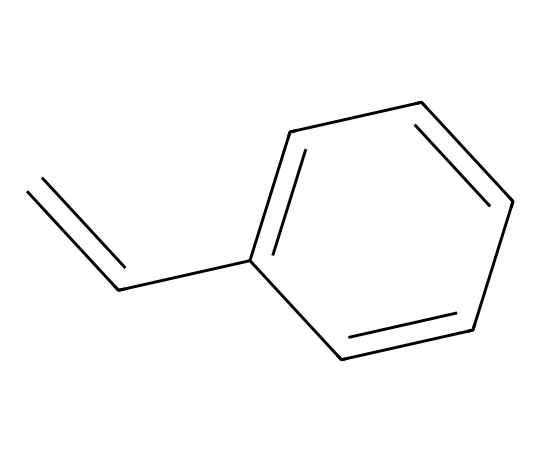What is the molecular formula of styrene? To determine the molecular formula, we first count the number of carbons (C) and hydrogens (H) in the structure. There are 8 carbon atoms and 8 hydrogen atoms. Thus, the molecular formula can be written as C8H8.
Answer: C8H8 How many double bonds are present in styrene? By examining the structure, we see one double bond between the first carbon (C) and the second carbon (C). Therefore, there is one double bond in the chemical structure.
Answer: 1 Which type of hybridization is present at the double bond of styrene? The carbon atoms involved in the double bond undergo sp2 hybridization due to one sigma bond and one pi bond formed. Thus, the hybridization at the double bond is sp2.
Answer: sp2 What type of polymer does styrene typically produce? Styrene is typically used to produce polystyrene, a well-known synthetic polymer used in various applications. Thus, the polymer produced from styrene is known as polystyrene.
Answer: polystyrene What property of styrene contributes to its use in copolymerization? The presence of the vinyl group (C=C) in styrene is a significant feature that allows it to react with other monomers, making it an excellent candidate for copolymerization. Thus, the property contributing to copolymerization is the vinyl group.
Answer: vinyl group What is the primary industrial application of styrene-derived polymers? Styrene-derived polymers, particularly polystyrene, are widely used in the production of foam products, such as packaging materials and insulation. Therefore, the primary application is foam products.
Answer: foam products What feature of styrene's structure enhances its reactivity in polymerization? The presence of the activated double bond in the vinyl group makes styrene highly reactive in polymerization processes. Hence, the feature enhancing reactivity is the activated double bond.
Answer: activated double bond 